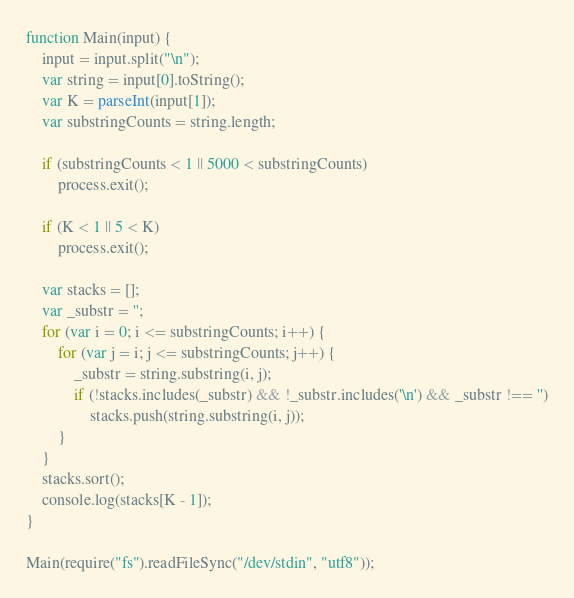<code> <loc_0><loc_0><loc_500><loc_500><_JavaScript_>
function Main(input) {
    input = input.split("\n");
    var string = input[0].toString();
    var K = parseInt(input[1]);
    var substringCounts = string.length;

    if (substringCounts < 1 || 5000 < substringCounts)
        process.exit();

    if (K < 1 || 5 < K)
        process.exit();

    var stacks = [];
    var _substr = '';
    for (var i = 0; i <= substringCounts; i++) {
        for (var j = i; j <= substringCounts; j++) {
            _substr = string.substring(i, j);
            if (!stacks.includes(_substr) && !_substr.includes('\n') && _substr !== '')
                stacks.push(string.substring(i, j));
        }
    }
    stacks.sort();
    console.log(stacks[K - 1]);
}

Main(require("fs").readFileSync("/dev/stdin", "utf8"));
</code> 